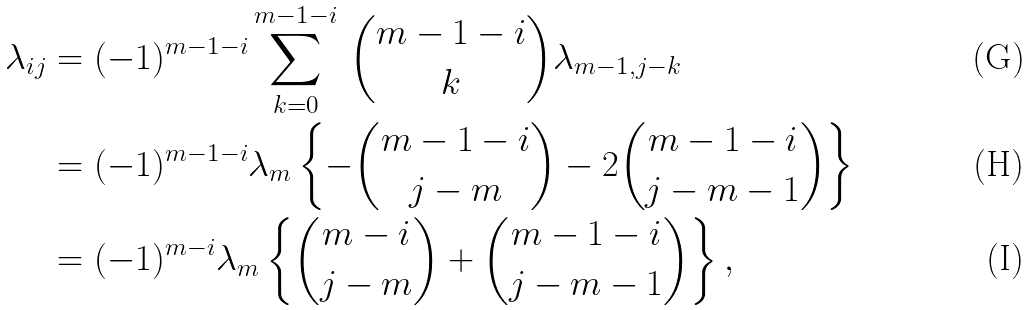Convert formula to latex. <formula><loc_0><loc_0><loc_500><loc_500>\lambda _ { i j } & = ( - 1 ) ^ { m - 1 - i } \sum _ { k = 0 } ^ { m - 1 - i } \, { m - 1 - i \choose k } \lambda _ { m - 1 , j - k } \\ & = ( - 1 ) ^ { m - 1 - i } \lambda _ { m } \left \{ - { m - 1 - i \choose j - m } - 2 { m - 1 - i \choose j - m - 1 } \right \} \\ & = ( - 1 ) ^ { m - i } \lambda _ { m } \left \{ { m - i \choose j - m } + { m - 1 - i \choose j - m - 1 } \right \} ,</formula> 